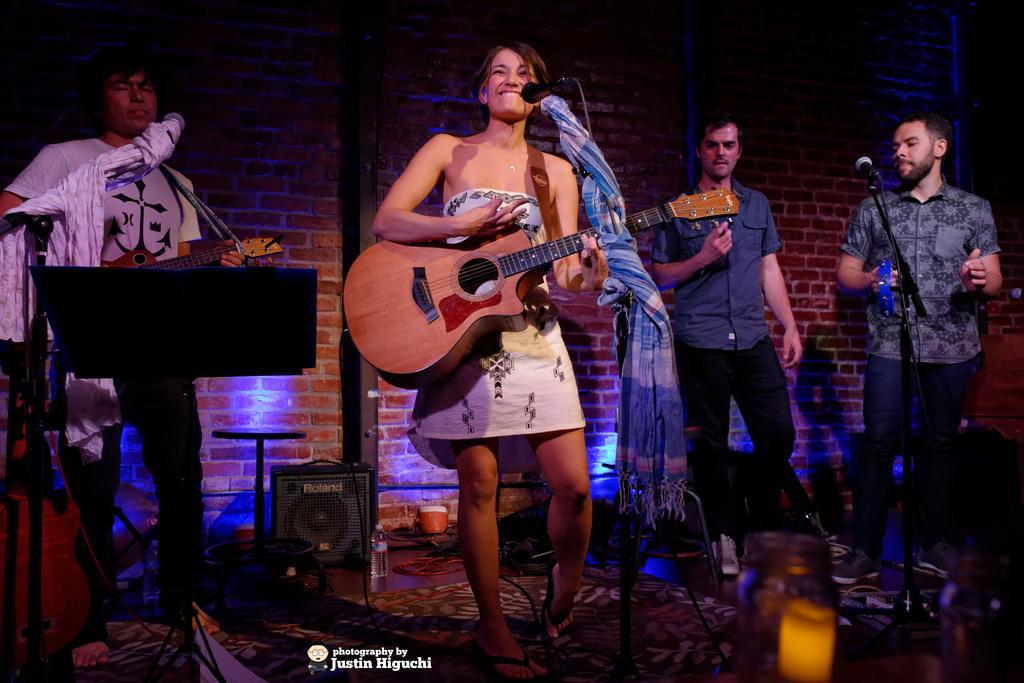Could you give a brief overview of what you see in this image? This image is taken in a concert. There are four people on the stage, three men and a woman. In the middle of the image a woman is standing and holding a guitar in her hand and singing in a mic. In the left side of the image a man is standing and holding a guitar in his hand. In the right side of the image a man is standing and playing a music. At the background there is a wall and lights. At the bottom of the image there is a floor with a mat. 